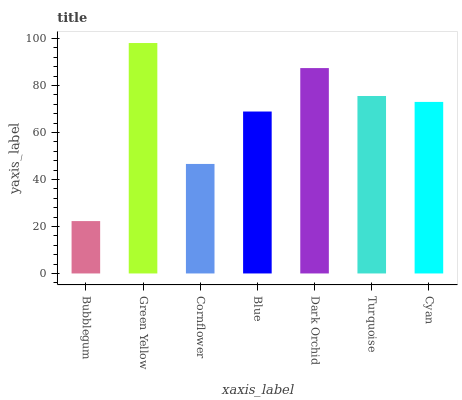Is Bubblegum the minimum?
Answer yes or no. Yes. Is Green Yellow the maximum?
Answer yes or no. Yes. Is Cornflower the minimum?
Answer yes or no. No. Is Cornflower the maximum?
Answer yes or no. No. Is Green Yellow greater than Cornflower?
Answer yes or no. Yes. Is Cornflower less than Green Yellow?
Answer yes or no. Yes. Is Cornflower greater than Green Yellow?
Answer yes or no. No. Is Green Yellow less than Cornflower?
Answer yes or no. No. Is Cyan the high median?
Answer yes or no. Yes. Is Cyan the low median?
Answer yes or no. Yes. Is Blue the high median?
Answer yes or no. No. Is Turquoise the low median?
Answer yes or no. No. 